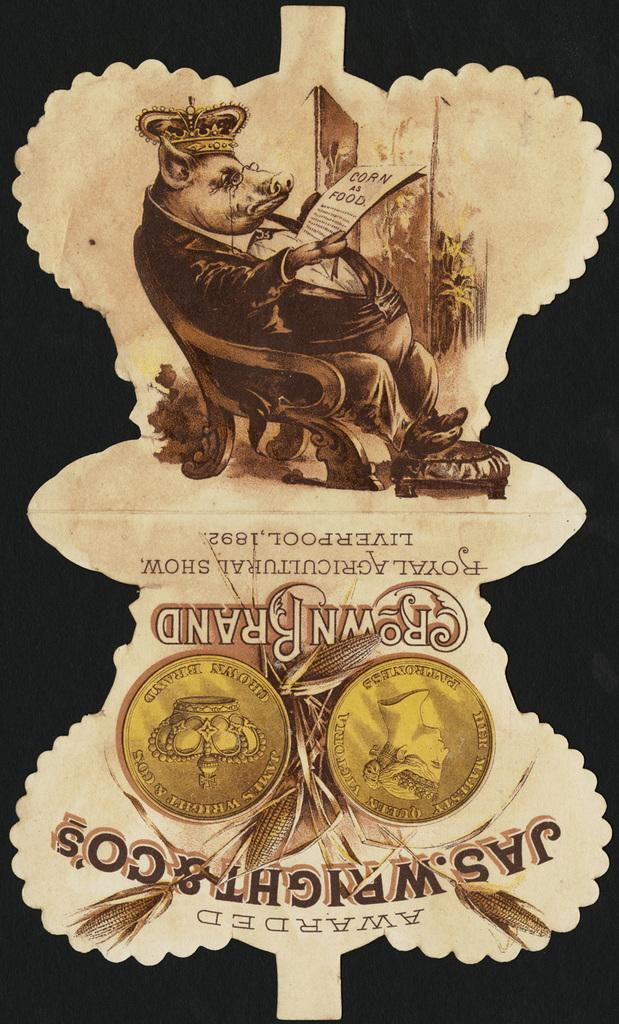<image>
Relay a brief, clear account of the picture shown. A piece of paper that talks about an event in 1982. 